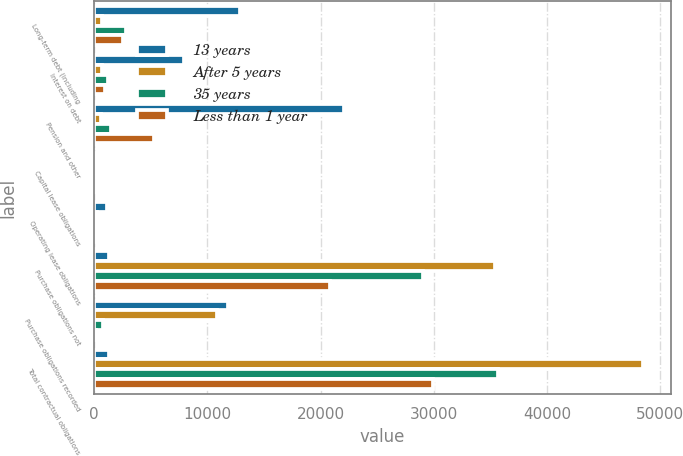Convert chart to OTSL. <chart><loc_0><loc_0><loc_500><loc_500><stacked_bar_chart><ecel><fcel>Long-term debt (including<fcel>Interest on debt<fcel>Pension and other<fcel>Capital lease obligations<fcel>Operating lease obligations<fcel>Purchase obligations not<fcel>Purchase obligations recorded<fcel>Total contractual obligations<nl><fcel>13 years<fcel>12846<fcel>7981<fcel>22038<fcel>76<fcel>1158<fcel>1344<fcel>11793<fcel>1344<nl><fcel>After 5 years<fcel>680<fcel>664<fcel>634<fcel>14<fcel>213<fcel>35387<fcel>10893<fcel>48485<nl><fcel>35 years<fcel>2815<fcel>1204<fcel>1484<fcel>28<fcel>300<fcel>29070<fcel>765<fcel>35666<nl><fcel>Less than 1 year<fcel>2547<fcel>934<fcel>5304<fcel>22<fcel>188<fcel>20821<fcel>131<fcel>29947<nl></chart> 